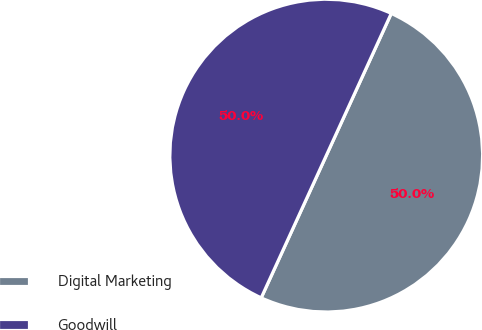Convert chart to OTSL. <chart><loc_0><loc_0><loc_500><loc_500><pie_chart><fcel>Digital Marketing<fcel>Goodwill<nl><fcel>50.0%<fcel>50.0%<nl></chart> 